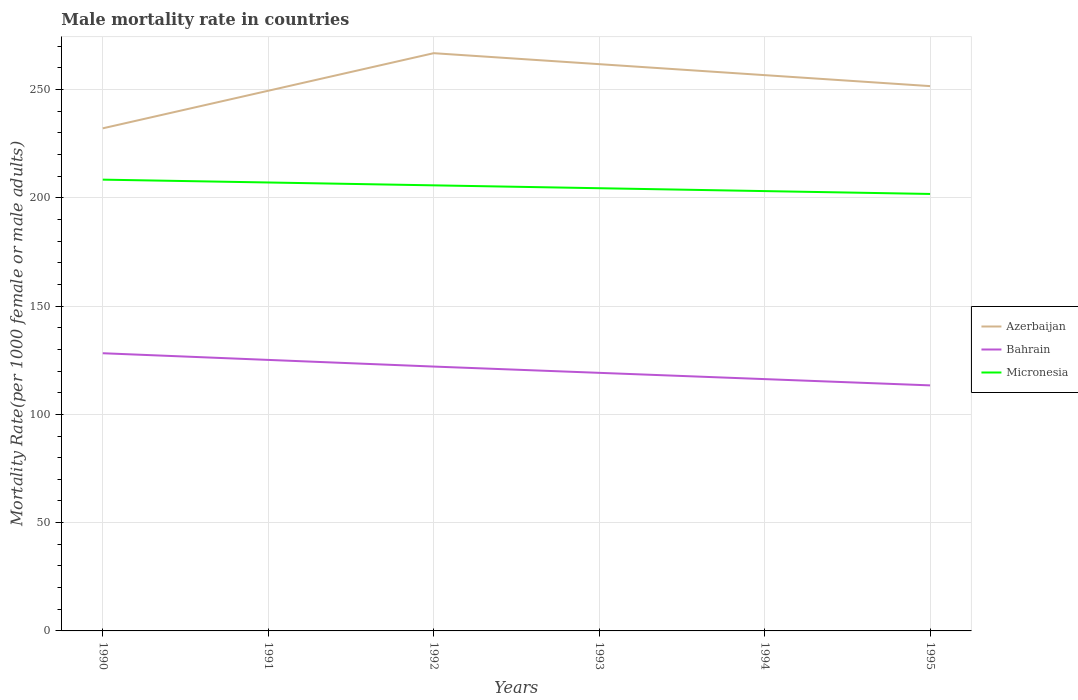Across all years, what is the maximum male mortality rate in Azerbaijan?
Give a very brief answer. 232.08. What is the total male mortality rate in Micronesia in the graph?
Your response must be concise. 1.32. What is the difference between the highest and the second highest male mortality rate in Bahrain?
Provide a succinct answer. 14.84. How many lines are there?
Offer a very short reply. 3. How many years are there in the graph?
Make the answer very short. 6. Does the graph contain grids?
Ensure brevity in your answer.  Yes. What is the title of the graph?
Keep it short and to the point. Male mortality rate in countries. What is the label or title of the Y-axis?
Your answer should be very brief. Mortality Rate(per 1000 female or male adults). What is the Mortality Rate(per 1000 female or male adults) of Azerbaijan in 1990?
Give a very brief answer. 232.08. What is the Mortality Rate(per 1000 female or male adults) of Bahrain in 1990?
Make the answer very short. 128.22. What is the Mortality Rate(per 1000 female or male adults) in Micronesia in 1990?
Your answer should be very brief. 208.38. What is the Mortality Rate(per 1000 female or male adults) in Azerbaijan in 1991?
Your answer should be very brief. 249.43. What is the Mortality Rate(per 1000 female or male adults) of Bahrain in 1991?
Give a very brief answer. 125.14. What is the Mortality Rate(per 1000 female or male adults) in Micronesia in 1991?
Provide a succinct answer. 207.06. What is the Mortality Rate(per 1000 female or male adults) in Azerbaijan in 1992?
Offer a terse response. 266.77. What is the Mortality Rate(per 1000 female or male adults) of Bahrain in 1992?
Offer a terse response. 122.07. What is the Mortality Rate(per 1000 female or male adults) in Micronesia in 1992?
Offer a very short reply. 205.75. What is the Mortality Rate(per 1000 female or male adults) in Azerbaijan in 1993?
Your answer should be very brief. 261.71. What is the Mortality Rate(per 1000 female or male adults) of Bahrain in 1993?
Keep it short and to the point. 119.17. What is the Mortality Rate(per 1000 female or male adults) of Micronesia in 1993?
Provide a succinct answer. 204.42. What is the Mortality Rate(per 1000 female or male adults) in Azerbaijan in 1994?
Keep it short and to the point. 256.64. What is the Mortality Rate(per 1000 female or male adults) of Bahrain in 1994?
Keep it short and to the point. 116.28. What is the Mortality Rate(per 1000 female or male adults) in Micronesia in 1994?
Keep it short and to the point. 203.09. What is the Mortality Rate(per 1000 female or male adults) in Azerbaijan in 1995?
Your answer should be very brief. 251.57. What is the Mortality Rate(per 1000 female or male adults) in Bahrain in 1995?
Offer a terse response. 113.38. What is the Mortality Rate(per 1000 female or male adults) of Micronesia in 1995?
Keep it short and to the point. 201.77. Across all years, what is the maximum Mortality Rate(per 1000 female or male adults) in Azerbaijan?
Give a very brief answer. 266.77. Across all years, what is the maximum Mortality Rate(per 1000 female or male adults) of Bahrain?
Provide a succinct answer. 128.22. Across all years, what is the maximum Mortality Rate(per 1000 female or male adults) in Micronesia?
Offer a very short reply. 208.38. Across all years, what is the minimum Mortality Rate(per 1000 female or male adults) in Azerbaijan?
Provide a succinct answer. 232.08. Across all years, what is the minimum Mortality Rate(per 1000 female or male adults) of Bahrain?
Keep it short and to the point. 113.38. Across all years, what is the minimum Mortality Rate(per 1000 female or male adults) of Micronesia?
Provide a succinct answer. 201.77. What is the total Mortality Rate(per 1000 female or male adults) in Azerbaijan in the graph?
Offer a very short reply. 1518.19. What is the total Mortality Rate(per 1000 female or male adults) in Bahrain in the graph?
Offer a terse response. 724.26. What is the total Mortality Rate(per 1000 female or male adults) of Micronesia in the graph?
Ensure brevity in your answer.  1230.48. What is the difference between the Mortality Rate(per 1000 female or male adults) in Azerbaijan in 1990 and that in 1991?
Give a very brief answer. -17.35. What is the difference between the Mortality Rate(per 1000 female or male adults) of Bahrain in 1990 and that in 1991?
Ensure brevity in your answer.  3.08. What is the difference between the Mortality Rate(per 1000 female or male adults) in Micronesia in 1990 and that in 1991?
Give a very brief answer. 1.32. What is the difference between the Mortality Rate(per 1000 female or male adults) of Azerbaijan in 1990 and that in 1992?
Provide a short and direct response. -34.69. What is the difference between the Mortality Rate(per 1000 female or male adults) in Bahrain in 1990 and that in 1992?
Provide a succinct answer. 6.16. What is the difference between the Mortality Rate(per 1000 female or male adults) in Micronesia in 1990 and that in 1992?
Your answer should be compact. 2.63. What is the difference between the Mortality Rate(per 1000 female or male adults) of Azerbaijan in 1990 and that in 1993?
Give a very brief answer. -29.62. What is the difference between the Mortality Rate(per 1000 female or male adults) in Bahrain in 1990 and that in 1993?
Your answer should be very brief. 9.05. What is the difference between the Mortality Rate(per 1000 female or male adults) of Micronesia in 1990 and that in 1993?
Offer a very short reply. 3.96. What is the difference between the Mortality Rate(per 1000 female or male adults) of Azerbaijan in 1990 and that in 1994?
Make the answer very short. -24.56. What is the difference between the Mortality Rate(per 1000 female or male adults) of Bahrain in 1990 and that in 1994?
Offer a terse response. 11.94. What is the difference between the Mortality Rate(per 1000 female or male adults) of Micronesia in 1990 and that in 1994?
Provide a succinct answer. 5.29. What is the difference between the Mortality Rate(per 1000 female or male adults) in Azerbaijan in 1990 and that in 1995?
Your answer should be compact. -19.49. What is the difference between the Mortality Rate(per 1000 female or male adults) of Bahrain in 1990 and that in 1995?
Your response must be concise. 14.84. What is the difference between the Mortality Rate(per 1000 female or male adults) of Micronesia in 1990 and that in 1995?
Make the answer very short. 6.61. What is the difference between the Mortality Rate(per 1000 female or male adults) of Azerbaijan in 1991 and that in 1992?
Give a very brief answer. -17.35. What is the difference between the Mortality Rate(per 1000 female or male adults) in Bahrain in 1991 and that in 1992?
Your answer should be compact. 3.08. What is the difference between the Mortality Rate(per 1000 female or male adults) in Micronesia in 1991 and that in 1992?
Make the answer very short. 1.32. What is the difference between the Mortality Rate(per 1000 female or male adults) in Azerbaijan in 1991 and that in 1993?
Offer a terse response. -12.28. What is the difference between the Mortality Rate(per 1000 female or male adults) in Bahrain in 1991 and that in 1993?
Provide a succinct answer. 5.97. What is the difference between the Mortality Rate(per 1000 female or male adults) of Micronesia in 1991 and that in 1993?
Keep it short and to the point. 2.64. What is the difference between the Mortality Rate(per 1000 female or male adults) of Azerbaijan in 1991 and that in 1994?
Ensure brevity in your answer.  -7.21. What is the difference between the Mortality Rate(per 1000 female or male adults) in Bahrain in 1991 and that in 1994?
Your response must be concise. 8.87. What is the difference between the Mortality Rate(per 1000 female or male adults) in Micronesia in 1991 and that in 1994?
Give a very brief answer. 3.97. What is the difference between the Mortality Rate(per 1000 female or male adults) in Azerbaijan in 1991 and that in 1995?
Give a very brief answer. -2.14. What is the difference between the Mortality Rate(per 1000 female or male adults) of Bahrain in 1991 and that in 1995?
Make the answer very short. 11.76. What is the difference between the Mortality Rate(per 1000 female or male adults) of Micronesia in 1991 and that in 1995?
Offer a terse response. 5.3. What is the difference between the Mortality Rate(per 1000 female or male adults) in Azerbaijan in 1992 and that in 1993?
Give a very brief answer. 5.07. What is the difference between the Mortality Rate(per 1000 female or male adults) of Bahrain in 1992 and that in 1993?
Provide a short and direct response. 2.89. What is the difference between the Mortality Rate(per 1000 female or male adults) of Micronesia in 1992 and that in 1993?
Offer a very short reply. 1.33. What is the difference between the Mortality Rate(per 1000 female or male adults) of Azerbaijan in 1992 and that in 1994?
Give a very brief answer. 10.14. What is the difference between the Mortality Rate(per 1000 female or male adults) of Bahrain in 1992 and that in 1994?
Keep it short and to the point. 5.79. What is the difference between the Mortality Rate(per 1000 female or male adults) of Micronesia in 1992 and that in 1994?
Offer a terse response. 2.65. What is the difference between the Mortality Rate(per 1000 female or male adults) in Azerbaijan in 1992 and that in 1995?
Your answer should be very brief. 15.2. What is the difference between the Mortality Rate(per 1000 female or male adults) in Bahrain in 1992 and that in 1995?
Provide a short and direct response. 8.68. What is the difference between the Mortality Rate(per 1000 female or male adults) of Micronesia in 1992 and that in 1995?
Your response must be concise. 3.98. What is the difference between the Mortality Rate(per 1000 female or male adults) in Azerbaijan in 1993 and that in 1994?
Offer a terse response. 5.07. What is the difference between the Mortality Rate(per 1000 female or male adults) of Bahrain in 1993 and that in 1994?
Make the answer very short. 2.89. What is the difference between the Mortality Rate(per 1000 female or male adults) of Micronesia in 1993 and that in 1994?
Offer a very short reply. 1.33. What is the difference between the Mortality Rate(per 1000 female or male adults) of Azerbaijan in 1993 and that in 1995?
Your response must be concise. 10.14. What is the difference between the Mortality Rate(per 1000 female or male adults) of Bahrain in 1993 and that in 1995?
Provide a succinct answer. 5.79. What is the difference between the Mortality Rate(per 1000 female or male adults) of Micronesia in 1993 and that in 1995?
Provide a short and direct response. 2.65. What is the difference between the Mortality Rate(per 1000 female or male adults) in Azerbaijan in 1994 and that in 1995?
Offer a very short reply. 5.07. What is the difference between the Mortality Rate(per 1000 female or male adults) of Bahrain in 1994 and that in 1995?
Give a very brief answer. 2.89. What is the difference between the Mortality Rate(per 1000 female or male adults) in Micronesia in 1994 and that in 1995?
Offer a very short reply. 1.33. What is the difference between the Mortality Rate(per 1000 female or male adults) in Azerbaijan in 1990 and the Mortality Rate(per 1000 female or male adults) in Bahrain in 1991?
Ensure brevity in your answer.  106.94. What is the difference between the Mortality Rate(per 1000 female or male adults) of Azerbaijan in 1990 and the Mortality Rate(per 1000 female or male adults) of Micronesia in 1991?
Your response must be concise. 25.02. What is the difference between the Mortality Rate(per 1000 female or male adults) in Bahrain in 1990 and the Mortality Rate(per 1000 female or male adults) in Micronesia in 1991?
Offer a very short reply. -78.84. What is the difference between the Mortality Rate(per 1000 female or male adults) of Azerbaijan in 1990 and the Mortality Rate(per 1000 female or male adults) of Bahrain in 1992?
Provide a succinct answer. 110.02. What is the difference between the Mortality Rate(per 1000 female or male adults) of Azerbaijan in 1990 and the Mortality Rate(per 1000 female or male adults) of Micronesia in 1992?
Your answer should be very brief. 26.33. What is the difference between the Mortality Rate(per 1000 female or male adults) of Bahrain in 1990 and the Mortality Rate(per 1000 female or male adults) of Micronesia in 1992?
Your answer should be compact. -77.53. What is the difference between the Mortality Rate(per 1000 female or male adults) of Azerbaijan in 1990 and the Mortality Rate(per 1000 female or male adults) of Bahrain in 1993?
Offer a terse response. 112.91. What is the difference between the Mortality Rate(per 1000 female or male adults) of Azerbaijan in 1990 and the Mortality Rate(per 1000 female or male adults) of Micronesia in 1993?
Give a very brief answer. 27.66. What is the difference between the Mortality Rate(per 1000 female or male adults) of Bahrain in 1990 and the Mortality Rate(per 1000 female or male adults) of Micronesia in 1993?
Your answer should be very brief. -76.2. What is the difference between the Mortality Rate(per 1000 female or male adults) of Azerbaijan in 1990 and the Mortality Rate(per 1000 female or male adults) of Bahrain in 1994?
Provide a short and direct response. 115.8. What is the difference between the Mortality Rate(per 1000 female or male adults) in Azerbaijan in 1990 and the Mortality Rate(per 1000 female or male adults) in Micronesia in 1994?
Your response must be concise. 28.99. What is the difference between the Mortality Rate(per 1000 female or male adults) of Bahrain in 1990 and the Mortality Rate(per 1000 female or male adults) of Micronesia in 1994?
Provide a short and direct response. -74.87. What is the difference between the Mortality Rate(per 1000 female or male adults) in Azerbaijan in 1990 and the Mortality Rate(per 1000 female or male adults) in Bahrain in 1995?
Keep it short and to the point. 118.7. What is the difference between the Mortality Rate(per 1000 female or male adults) of Azerbaijan in 1990 and the Mortality Rate(per 1000 female or male adults) of Micronesia in 1995?
Give a very brief answer. 30.31. What is the difference between the Mortality Rate(per 1000 female or male adults) in Bahrain in 1990 and the Mortality Rate(per 1000 female or male adults) in Micronesia in 1995?
Make the answer very short. -73.55. What is the difference between the Mortality Rate(per 1000 female or male adults) of Azerbaijan in 1991 and the Mortality Rate(per 1000 female or male adults) of Bahrain in 1992?
Provide a short and direct response. 127.36. What is the difference between the Mortality Rate(per 1000 female or male adults) of Azerbaijan in 1991 and the Mortality Rate(per 1000 female or male adults) of Micronesia in 1992?
Provide a short and direct response. 43.68. What is the difference between the Mortality Rate(per 1000 female or male adults) of Bahrain in 1991 and the Mortality Rate(per 1000 female or male adults) of Micronesia in 1992?
Keep it short and to the point. -80.6. What is the difference between the Mortality Rate(per 1000 female or male adults) in Azerbaijan in 1991 and the Mortality Rate(per 1000 female or male adults) in Bahrain in 1993?
Provide a short and direct response. 130.25. What is the difference between the Mortality Rate(per 1000 female or male adults) in Azerbaijan in 1991 and the Mortality Rate(per 1000 female or male adults) in Micronesia in 1993?
Provide a succinct answer. 45.01. What is the difference between the Mortality Rate(per 1000 female or male adults) in Bahrain in 1991 and the Mortality Rate(per 1000 female or male adults) in Micronesia in 1993?
Provide a succinct answer. -79.28. What is the difference between the Mortality Rate(per 1000 female or male adults) in Azerbaijan in 1991 and the Mortality Rate(per 1000 female or male adults) in Bahrain in 1994?
Offer a terse response. 133.15. What is the difference between the Mortality Rate(per 1000 female or male adults) of Azerbaijan in 1991 and the Mortality Rate(per 1000 female or male adults) of Micronesia in 1994?
Provide a succinct answer. 46.33. What is the difference between the Mortality Rate(per 1000 female or male adults) of Bahrain in 1991 and the Mortality Rate(per 1000 female or male adults) of Micronesia in 1994?
Offer a terse response. -77.95. What is the difference between the Mortality Rate(per 1000 female or male adults) of Azerbaijan in 1991 and the Mortality Rate(per 1000 female or male adults) of Bahrain in 1995?
Your answer should be very brief. 136.04. What is the difference between the Mortality Rate(per 1000 female or male adults) of Azerbaijan in 1991 and the Mortality Rate(per 1000 female or male adults) of Micronesia in 1995?
Offer a very short reply. 47.66. What is the difference between the Mortality Rate(per 1000 female or male adults) of Bahrain in 1991 and the Mortality Rate(per 1000 female or male adults) of Micronesia in 1995?
Offer a terse response. -76.62. What is the difference between the Mortality Rate(per 1000 female or male adults) of Azerbaijan in 1992 and the Mortality Rate(per 1000 female or male adults) of Bahrain in 1993?
Keep it short and to the point. 147.6. What is the difference between the Mortality Rate(per 1000 female or male adults) of Azerbaijan in 1992 and the Mortality Rate(per 1000 female or male adults) of Micronesia in 1993?
Your answer should be very brief. 62.35. What is the difference between the Mortality Rate(per 1000 female or male adults) in Bahrain in 1992 and the Mortality Rate(per 1000 female or male adults) in Micronesia in 1993?
Your answer should be compact. -82.36. What is the difference between the Mortality Rate(per 1000 female or male adults) of Azerbaijan in 1992 and the Mortality Rate(per 1000 female or male adults) of Bahrain in 1994?
Offer a terse response. 150.5. What is the difference between the Mortality Rate(per 1000 female or male adults) of Azerbaijan in 1992 and the Mortality Rate(per 1000 female or male adults) of Micronesia in 1994?
Make the answer very short. 63.68. What is the difference between the Mortality Rate(per 1000 female or male adults) of Bahrain in 1992 and the Mortality Rate(per 1000 female or male adults) of Micronesia in 1994?
Your answer should be very brief. -81.03. What is the difference between the Mortality Rate(per 1000 female or male adults) in Azerbaijan in 1992 and the Mortality Rate(per 1000 female or male adults) in Bahrain in 1995?
Provide a short and direct response. 153.39. What is the difference between the Mortality Rate(per 1000 female or male adults) of Azerbaijan in 1992 and the Mortality Rate(per 1000 female or male adults) of Micronesia in 1995?
Offer a very short reply. 65. What is the difference between the Mortality Rate(per 1000 female or male adults) of Bahrain in 1992 and the Mortality Rate(per 1000 female or male adults) of Micronesia in 1995?
Your answer should be very brief. -79.7. What is the difference between the Mortality Rate(per 1000 female or male adults) of Azerbaijan in 1993 and the Mortality Rate(per 1000 female or male adults) of Bahrain in 1994?
Make the answer very short. 145.43. What is the difference between the Mortality Rate(per 1000 female or male adults) of Azerbaijan in 1993 and the Mortality Rate(per 1000 female or male adults) of Micronesia in 1994?
Your answer should be very brief. 58.61. What is the difference between the Mortality Rate(per 1000 female or male adults) in Bahrain in 1993 and the Mortality Rate(per 1000 female or male adults) in Micronesia in 1994?
Give a very brief answer. -83.92. What is the difference between the Mortality Rate(per 1000 female or male adults) of Azerbaijan in 1993 and the Mortality Rate(per 1000 female or male adults) of Bahrain in 1995?
Your answer should be compact. 148.32. What is the difference between the Mortality Rate(per 1000 female or male adults) of Azerbaijan in 1993 and the Mortality Rate(per 1000 female or male adults) of Micronesia in 1995?
Provide a succinct answer. 59.94. What is the difference between the Mortality Rate(per 1000 female or male adults) in Bahrain in 1993 and the Mortality Rate(per 1000 female or male adults) in Micronesia in 1995?
Provide a short and direct response. -82.6. What is the difference between the Mortality Rate(per 1000 female or male adults) in Azerbaijan in 1994 and the Mortality Rate(per 1000 female or male adults) in Bahrain in 1995?
Your answer should be compact. 143.25. What is the difference between the Mortality Rate(per 1000 female or male adults) of Azerbaijan in 1994 and the Mortality Rate(per 1000 female or male adults) of Micronesia in 1995?
Your answer should be very brief. 54.87. What is the difference between the Mortality Rate(per 1000 female or male adults) in Bahrain in 1994 and the Mortality Rate(per 1000 female or male adults) in Micronesia in 1995?
Provide a short and direct response. -85.49. What is the average Mortality Rate(per 1000 female or male adults) in Azerbaijan per year?
Offer a very short reply. 253.03. What is the average Mortality Rate(per 1000 female or male adults) of Bahrain per year?
Give a very brief answer. 120.71. What is the average Mortality Rate(per 1000 female or male adults) of Micronesia per year?
Offer a very short reply. 205.08. In the year 1990, what is the difference between the Mortality Rate(per 1000 female or male adults) in Azerbaijan and Mortality Rate(per 1000 female or male adults) in Bahrain?
Keep it short and to the point. 103.86. In the year 1990, what is the difference between the Mortality Rate(per 1000 female or male adults) of Azerbaijan and Mortality Rate(per 1000 female or male adults) of Micronesia?
Provide a short and direct response. 23.7. In the year 1990, what is the difference between the Mortality Rate(per 1000 female or male adults) in Bahrain and Mortality Rate(per 1000 female or male adults) in Micronesia?
Offer a terse response. -80.16. In the year 1991, what is the difference between the Mortality Rate(per 1000 female or male adults) of Azerbaijan and Mortality Rate(per 1000 female or male adults) of Bahrain?
Ensure brevity in your answer.  124.28. In the year 1991, what is the difference between the Mortality Rate(per 1000 female or male adults) in Azerbaijan and Mortality Rate(per 1000 female or male adults) in Micronesia?
Offer a terse response. 42.36. In the year 1991, what is the difference between the Mortality Rate(per 1000 female or male adults) in Bahrain and Mortality Rate(per 1000 female or male adults) in Micronesia?
Keep it short and to the point. -81.92. In the year 1992, what is the difference between the Mortality Rate(per 1000 female or male adults) of Azerbaijan and Mortality Rate(per 1000 female or male adults) of Bahrain?
Your response must be concise. 144.71. In the year 1992, what is the difference between the Mortality Rate(per 1000 female or male adults) of Azerbaijan and Mortality Rate(per 1000 female or male adults) of Micronesia?
Ensure brevity in your answer.  61.02. In the year 1992, what is the difference between the Mortality Rate(per 1000 female or male adults) of Bahrain and Mortality Rate(per 1000 female or male adults) of Micronesia?
Offer a terse response. -83.68. In the year 1993, what is the difference between the Mortality Rate(per 1000 female or male adults) of Azerbaijan and Mortality Rate(per 1000 female or male adults) of Bahrain?
Provide a succinct answer. 142.53. In the year 1993, what is the difference between the Mortality Rate(per 1000 female or male adults) in Azerbaijan and Mortality Rate(per 1000 female or male adults) in Micronesia?
Offer a terse response. 57.28. In the year 1993, what is the difference between the Mortality Rate(per 1000 female or male adults) of Bahrain and Mortality Rate(per 1000 female or male adults) of Micronesia?
Offer a terse response. -85.25. In the year 1994, what is the difference between the Mortality Rate(per 1000 female or male adults) in Azerbaijan and Mortality Rate(per 1000 female or male adults) in Bahrain?
Your answer should be compact. 140.36. In the year 1994, what is the difference between the Mortality Rate(per 1000 female or male adults) in Azerbaijan and Mortality Rate(per 1000 female or male adults) in Micronesia?
Your response must be concise. 53.54. In the year 1994, what is the difference between the Mortality Rate(per 1000 female or male adults) in Bahrain and Mortality Rate(per 1000 female or male adults) in Micronesia?
Your response must be concise. -86.82. In the year 1995, what is the difference between the Mortality Rate(per 1000 female or male adults) of Azerbaijan and Mortality Rate(per 1000 female or male adults) of Bahrain?
Offer a terse response. 138.19. In the year 1995, what is the difference between the Mortality Rate(per 1000 female or male adults) in Azerbaijan and Mortality Rate(per 1000 female or male adults) in Micronesia?
Give a very brief answer. 49.8. In the year 1995, what is the difference between the Mortality Rate(per 1000 female or male adults) in Bahrain and Mortality Rate(per 1000 female or male adults) in Micronesia?
Offer a terse response. -88.39. What is the ratio of the Mortality Rate(per 1000 female or male adults) in Azerbaijan in 1990 to that in 1991?
Offer a very short reply. 0.93. What is the ratio of the Mortality Rate(per 1000 female or male adults) in Bahrain in 1990 to that in 1991?
Make the answer very short. 1.02. What is the ratio of the Mortality Rate(per 1000 female or male adults) of Micronesia in 1990 to that in 1991?
Keep it short and to the point. 1.01. What is the ratio of the Mortality Rate(per 1000 female or male adults) in Azerbaijan in 1990 to that in 1992?
Your answer should be compact. 0.87. What is the ratio of the Mortality Rate(per 1000 female or male adults) in Bahrain in 1990 to that in 1992?
Keep it short and to the point. 1.05. What is the ratio of the Mortality Rate(per 1000 female or male adults) of Micronesia in 1990 to that in 1992?
Your answer should be very brief. 1.01. What is the ratio of the Mortality Rate(per 1000 female or male adults) of Azerbaijan in 1990 to that in 1993?
Keep it short and to the point. 0.89. What is the ratio of the Mortality Rate(per 1000 female or male adults) in Bahrain in 1990 to that in 1993?
Provide a succinct answer. 1.08. What is the ratio of the Mortality Rate(per 1000 female or male adults) in Micronesia in 1990 to that in 1993?
Offer a very short reply. 1.02. What is the ratio of the Mortality Rate(per 1000 female or male adults) in Azerbaijan in 1990 to that in 1994?
Offer a very short reply. 0.9. What is the ratio of the Mortality Rate(per 1000 female or male adults) of Bahrain in 1990 to that in 1994?
Offer a very short reply. 1.1. What is the ratio of the Mortality Rate(per 1000 female or male adults) of Micronesia in 1990 to that in 1994?
Give a very brief answer. 1.03. What is the ratio of the Mortality Rate(per 1000 female or male adults) in Azerbaijan in 1990 to that in 1995?
Your answer should be compact. 0.92. What is the ratio of the Mortality Rate(per 1000 female or male adults) of Bahrain in 1990 to that in 1995?
Keep it short and to the point. 1.13. What is the ratio of the Mortality Rate(per 1000 female or male adults) of Micronesia in 1990 to that in 1995?
Your response must be concise. 1.03. What is the ratio of the Mortality Rate(per 1000 female or male adults) in Azerbaijan in 1991 to that in 1992?
Offer a terse response. 0.94. What is the ratio of the Mortality Rate(per 1000 female or male adults) in Bahrain in 1991 to that in 1992?
Offer a very short reply. 1.03. What is the ratio of the Mortality Rate(per 1000 female or male adults) in Micronesia in 1991 to that in 1992?
Provide a succinct answer. 1.01. What is the ratio of the Mortality Rate(per 1000 female or male adults) in Azerbaijan in 1991 to that in 1993?
Your answer should be very brief. 0.95. What is the ratio of the Mortality Rate(per 1000 female or male adults) in Bahrain in 1991 to that in 1993?
Your response must be concise. 1.05. What is the ratio of the Mortality Rate(per 1000 female or male adults) in Micronesia in 1991 to that in 1993?
Your response must be concise. 1.01. What is the ratio of the Mortality Rate(per 1000 female or male adults) of Azerbaijan in 1991 to that in 1994?
Provide a succinct answer. 0.97. What is the ratio of the Mortality Rate(per 1000 female or male adults) in Bahrain in 1991 to that in 1994?
Your answer should be very brief. 1.08. What is the ratio of the Mortality Rate(per 1000 female or male adults) in Micronesia in 1991 to that in 1994?
Give a very brief answer. 1.02. What is the ratio of the Mortality Rate(per 1000 female or male adults) of Azerbaijan in 1991 to that in 1995?
Make the answer very short. 0.99. What is the ratio of the Mortality Rate(per 1000 female or male adults) of Bahrain in 1991 to that in 1995?
Keep it short and to the point. 1.1. What is the ratio of the Mortality Rate(per 1000 female or male adults) in Micronesia in 1991 to that in 1995?
Make the answer very short. 1.03. What is the ratio of the Mortality Rate(per 1000 female or male adults) in Azerbaijan in 1992 to that in 1993?
Keep it short and to the point. 1.02. What is the ratio of the Mortality Rate(per 1000 female or male adults) in Bahrain in 1992 to that in 1993?
Provide a short and direct response. 1.02. What is the ratio of the Mortality Rate(per 1000 female or male adults) of Azerbaijan in 1992 to that in 1994?
Make the answer very short. 1.04. What is the ratio of the Mortality Rate(per 1000 female or male adults) in Bahrain in 1992 to that in 1994?
Your answer should be very brief. 1.05. What is the ratio of the Mortality Rate(per 1000 female or male adults) in Micronesia in 1992 to that in 1994?
Keep it short and to the point. 1.01. What is the ratio of the Mortality Rate(per 1000 female or male adults) in Azerbaijan in 1992 to that in 1995?
Ensure brevity in your answer.  1.06. What is the ratio of the Mortality Rate(per 1000 female or male adults) in Bahrain in 1992 to that in 1995?
Offer a very short reply. 1.08. What is the ratio of the Mortality Rate(per 1000 female or male adults) in Micronesia in 1992 to that in 1995?
Ensure brevity in your answer.  1.02. What is the ratio of the Mortality Rate(per 1000 female or male adults) of Azerbaijan in 1993 to that in 1994?
Ensure brevity in your answer.  1.02. What is the ratio of the Mortality Rate(per 1000 female or male adults) of Bahrain in 1993 to that in 1994?
Offer a terse response. 1.02. What is the ratio of the Mortality Rate(per 1000 female or male adults) of Azerbaijan in 1993 to that in 1995?
Provide a short and direct response. 1.04. What is the ratio of the Mortality Rate(per 1000 female or male adults) of Bahrain in 1993 to that in 1995?
Provide a short and direct response. 1.05. What is the ratio of the Mortality Rate(per 1000 female or male adults) of Micronesia in 1993 to that in 1995?
Provide a succinct answer. 1.01. What is the ratio of the Mortality Rate(per 1000 female or male adults) of Azerbaijan in 1994 to that in 1995?
Provide a short and direct response. 1.02. What is the ratio of the Mortality Rate(per 1000 female or male adults) in Bahrain in 1994 to that in 1995?
Your answer should be very brief. 1.03. What is the ratio of the Mortality Rate(per 1000 female or male adults) of Micronesia in 1994 to that in 1995?
Your response must be concise. 1.01. What is the difference between the highest and the second highest Mortality Rate(per 1000 female or male adults) in Azerbaijan?
Give a very brief answer. 5.07. What is the difference between the highest and the second highest Mortality Rate(per 1000 female or male adults) of Bahrain?
Your answer should be very brief. 3.08. What is the difference between the highest and the second highest Mortality Rate(per 1000 female or male adults) in Micronesia?
Offer a very short reply. 1.32. What is the difference between the highest and the lowest Mortality Rate(per 1000 female or male adults) in Azerbaijan?
Offer a very short reply. 34.69. What is the difference between the highest and the lowest Mortality Rate(per 1000 female or male adults) in Bahrain?
Provide a succinct answer. 14.84. What is the difference between the highest and the lowest Mortality Rate(per 1000 female or male adults) in Micronesia?
Offer a very short reply. 6.61. 